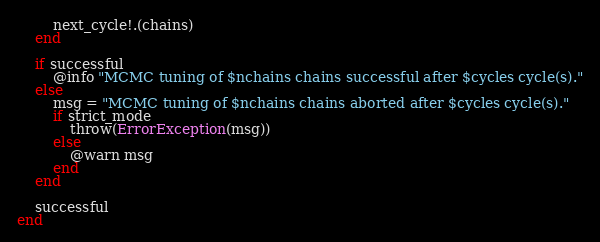<code> <loc_0><loc_0><loc_500><loc_500><_Julia_>
        next_cycle!.(chains)
    end

    if successful
        @info "MCMC tuning of $nchains chains successful after $cycles cycle(s)."
    else
        msg = "MCMC tuning of $nchains chains aborted after $cycles cycle(s)."
        if strict_mode
            throw(ErrorException(msg))
        else
            @warn msg
        end
    end

    successful
end
</code> 